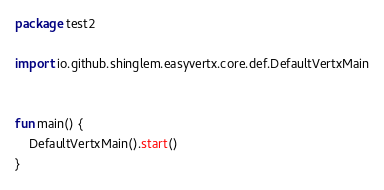Convert code to text. <code><loc_0><loc_0><loc_500><loc_500><_Kotlin_>package test2

import io.github.shinglem.easyvertx.core.def.DefaultVertxMain


fun main() {
    DefaultVertxMain().start()
}
</code> 